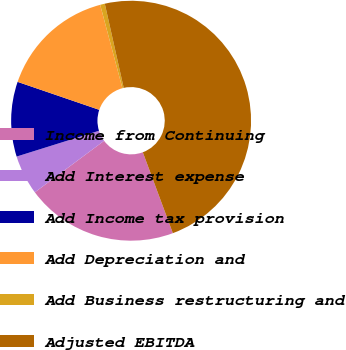<chart> <loc_0><loc_0><loc_500><loc_500><pie_chart><fcel>Income from Continuing<fcel>Add Interest expense<fcel>Add Income tax provision<fcel>Add Depreciation and<fcel>Add Business restructuring and<fcel>Adjusted EBITDA<nl><fcel>20.48%<fcel>5.35%<fcel>10.08%<fcel>15.6%<fcel>0.63%<fcel>47.86%<nl></chart> 